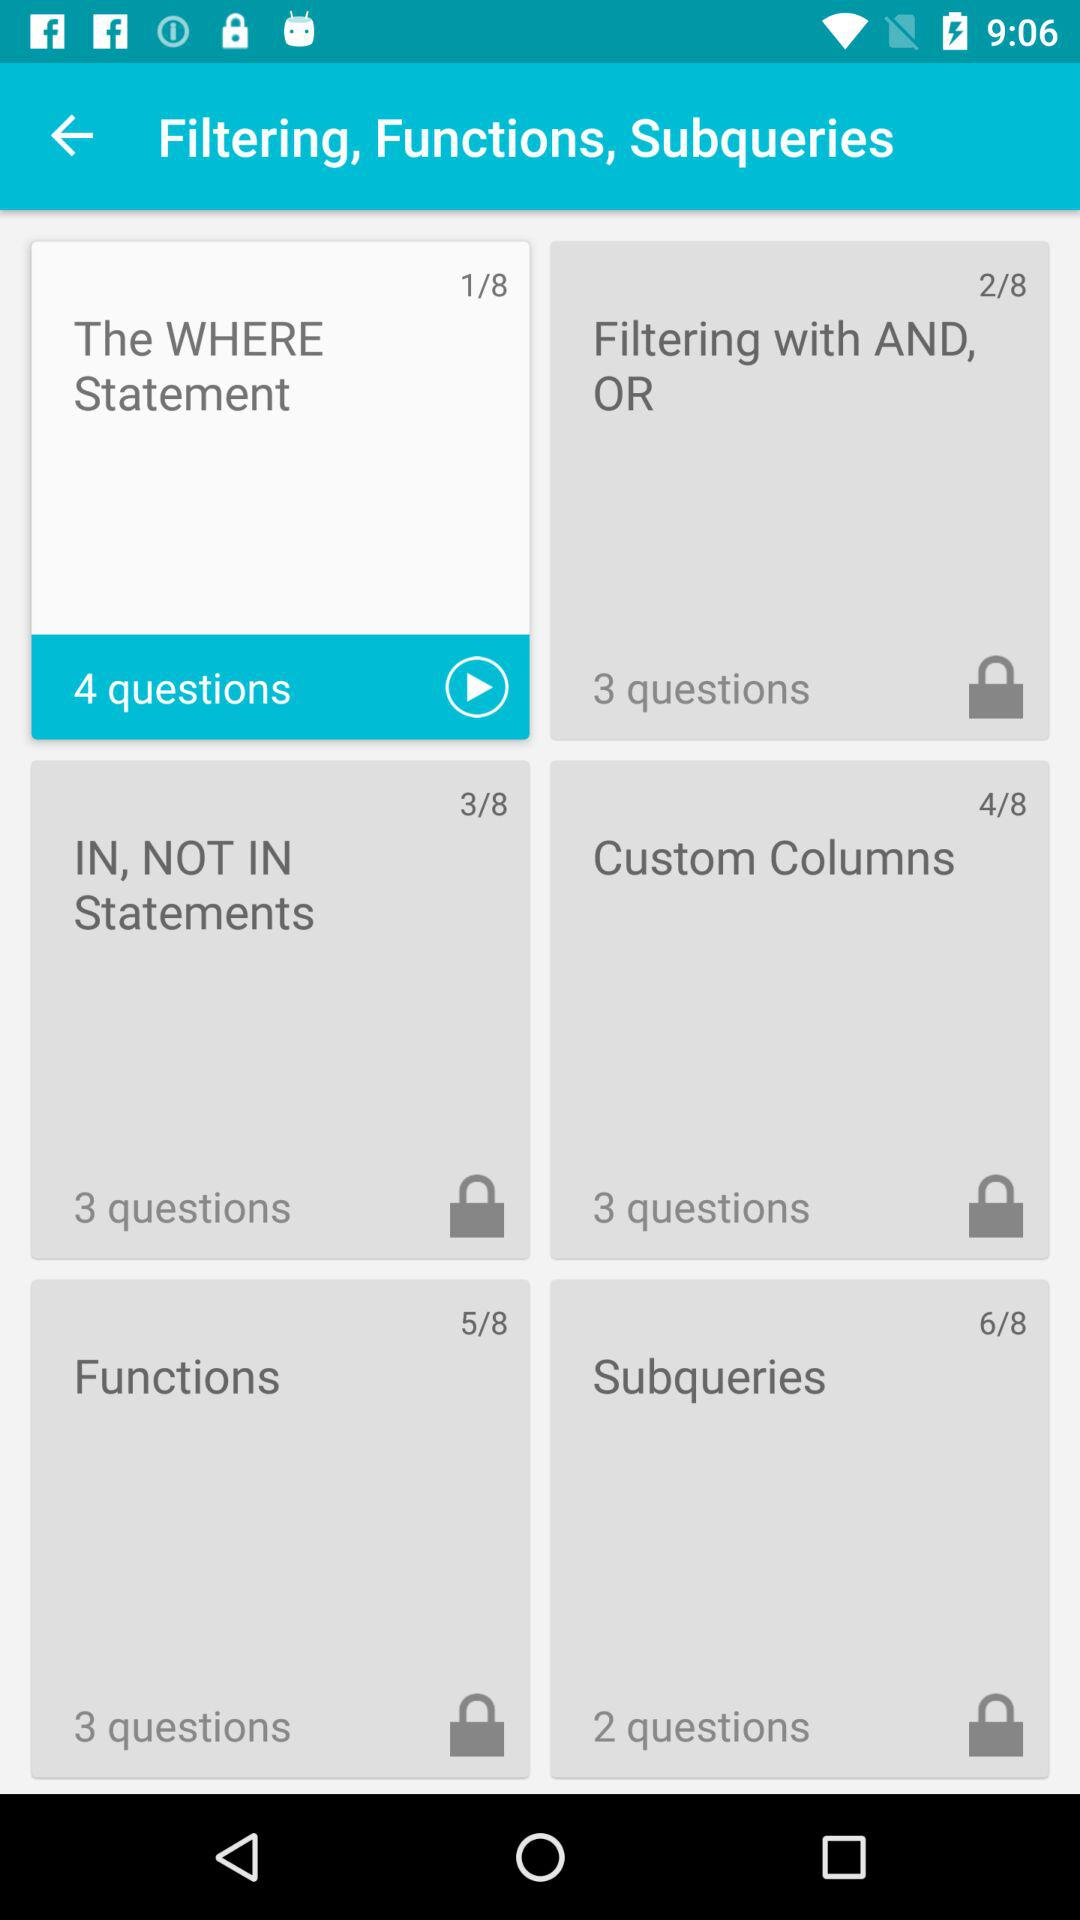Which slide has 2 questions? The slide that has 2 questions is "Subqueries". 